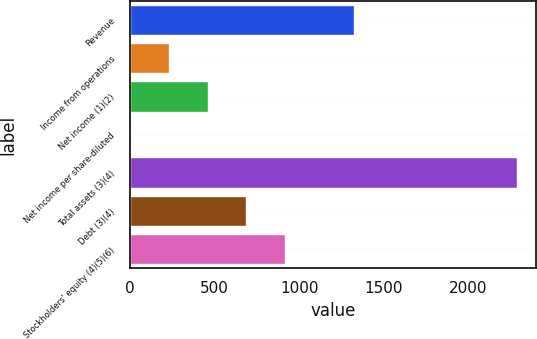<chart> <loc_0><loc_0><loc_500><loc_500><bar_chart><fcel>Revenue<fcel>Income from operations<fcel>Net income (1)(2)<fcel>Net income per share-diluted<fcel>Total assets (3)(4)<fcel>Debt (3)(4)<fcel>Stockholders' equity (4)(5)(6)<nl><fcel>1326.4<fcel>230.11<fcel>458.65<fcel>1.57<fcel>2287<fcel>687.19<fcel>915.73<nl></chart> 